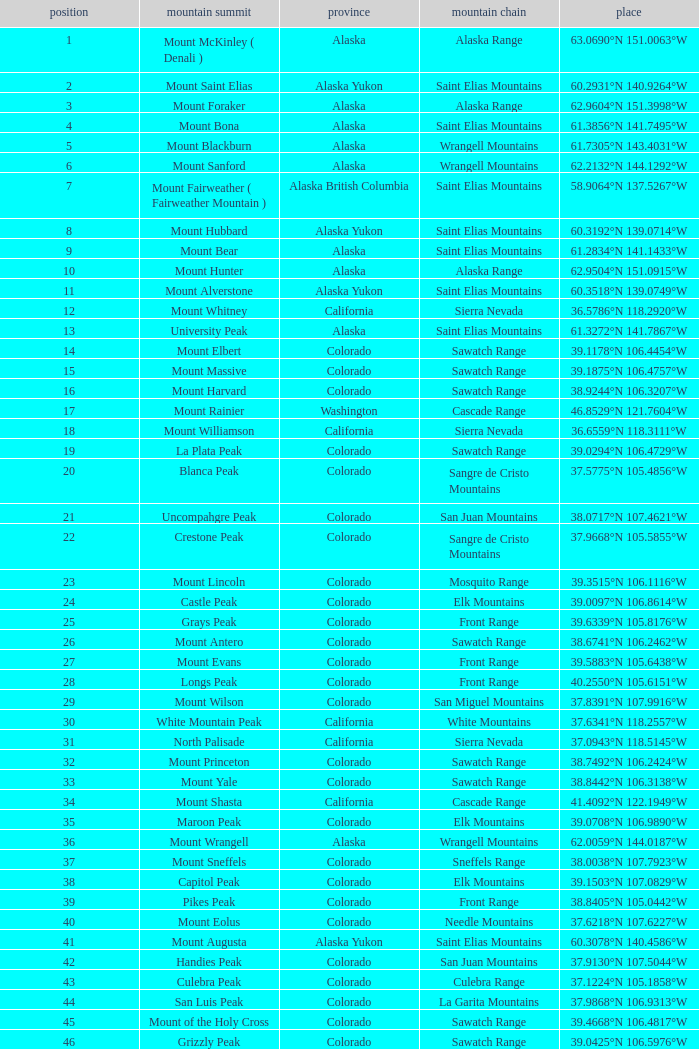What is the mountain range when the mountain peak is mauna kea? Island of Hawai ʻ i. 